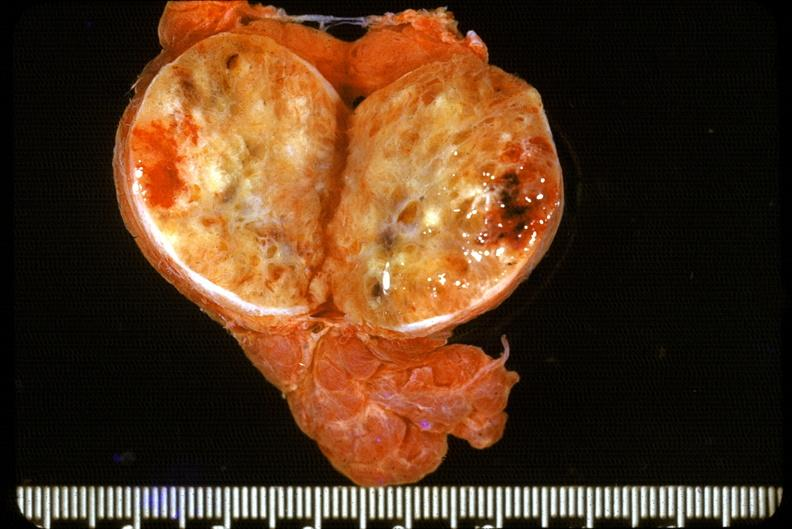does this image show thyroid, follicular adenoma?
Answer the question using a single word or phrase. Yes 